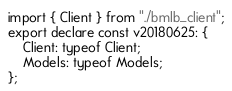<code> <loc_0><loc_0><loc_500><loc_500><_TypeScript_>import { Client } from "./bmlb_client";
export declare const v20180625: {
    Client: typeof Client;
    Models: typeof Models;
};
</code> 